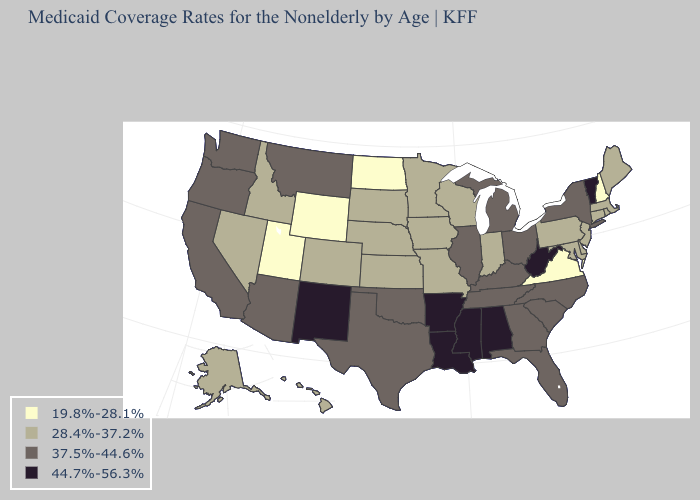Does Virginia have the lowest value in the USA?
Be succinct. Yes. What is the highest value in the West ?
Keep it brief. 44.7%-56.3%. Name the states that have a value in the range 19.8%-28.1%?
Short answer required. New Hampshire, North Dakota, Utah, Virginia, Wyoming. How many symbols are there in the legend?
Give a very brief answer. 4. Does New Hampshire have the highest value in the Northeast?
Answer briefly. No. What is the highest value in states that border Florida?
Give a very brief answer. 44.7%-56.3%. What is the value of Nevada?
Give a very brief answer. 28.4%-37.2%. Which states have the lowest value in the USA?
Short answer required. New Hampshire, North Dakota, Utah, Virginia, Wyoming. What is the value of Wyoming?
Be succinct. 19.8%-28.1%. Does Maine have a lower value than South Dakota?
Concise answer only. No. Does Arkansas have the highest value in the USA?
Be succinct. Yes. Among the states that border Oregon , does Nevada have the lowest value?
Concise answer only. Yes. Among the states that border New Hampshire , which have the highest value?
Short answer required. Vermont. What is the value of West Virginia?
Write a very short answer. 44.7%-56.3%. Which states hav the highest value in the MidWest?
Be succinct. Illinois, Michigan, Ohio. 